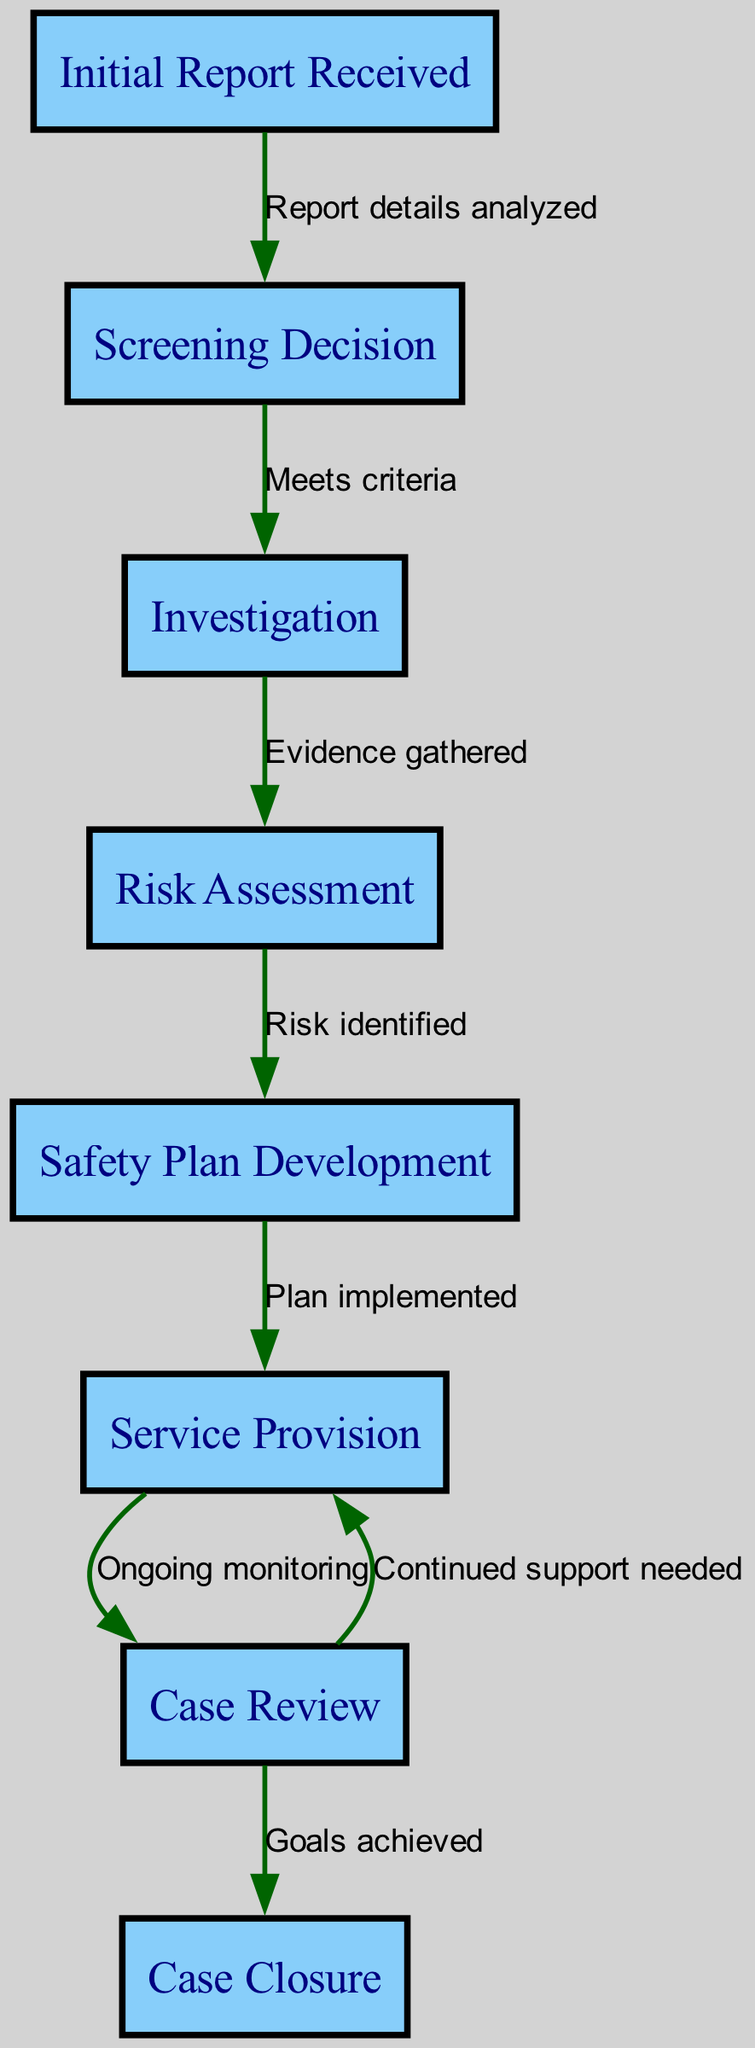What is the first step in the child protective services intervention process? The first node in the diagram is labeled "Initial Report Received," indicating that this is the starting point of the intervention process.
Answer: Initial Report Received How many nodes are in the diagram? By counting all the unique labeled nodes present, there are a total of eight nodes that represent the different steps in the intervention process.
Answer: 8 Which node comes after "Risk Assessment"? Following the node labeled "Risk Assessment," the next step is "Safety Plan Development," as indicated by the edge connecting these two nodes.
Answer: Safety Plan Development What action occurs after "Service Provision"? After the node "Service Provision," there is a case review which is the following step in the intervention process, represented by the directed edge from "Service Provision" to "Case Review."
Answer: Case Review What is required for a case to move from "Screening Decision" to "Investigation"? The transition from "Screening Decision" to "Investigation" occurs only if the criteria are met, as indicated by the edge labeled "Meets criteria."
Answer: Meets criteria How many edges are there in the diagram? There are a total of seven edges connecting the nodes, each representing the relationship between consecutive steps in the intervention process.
Answer: 7 What happens during "Case Review"? During the "Case Review," outcomes can vary; a case can either achieve its goals leading to case closure or require continued support, as indicated by the branching edges from this node.
Answer: Ongoing monitoring / Continued support needed What is the final step represented in the diagram? The last node in the flowchart is "Case Closure," which signifies the end of the intervention process after assessing progress.
Answer: Case Closure 